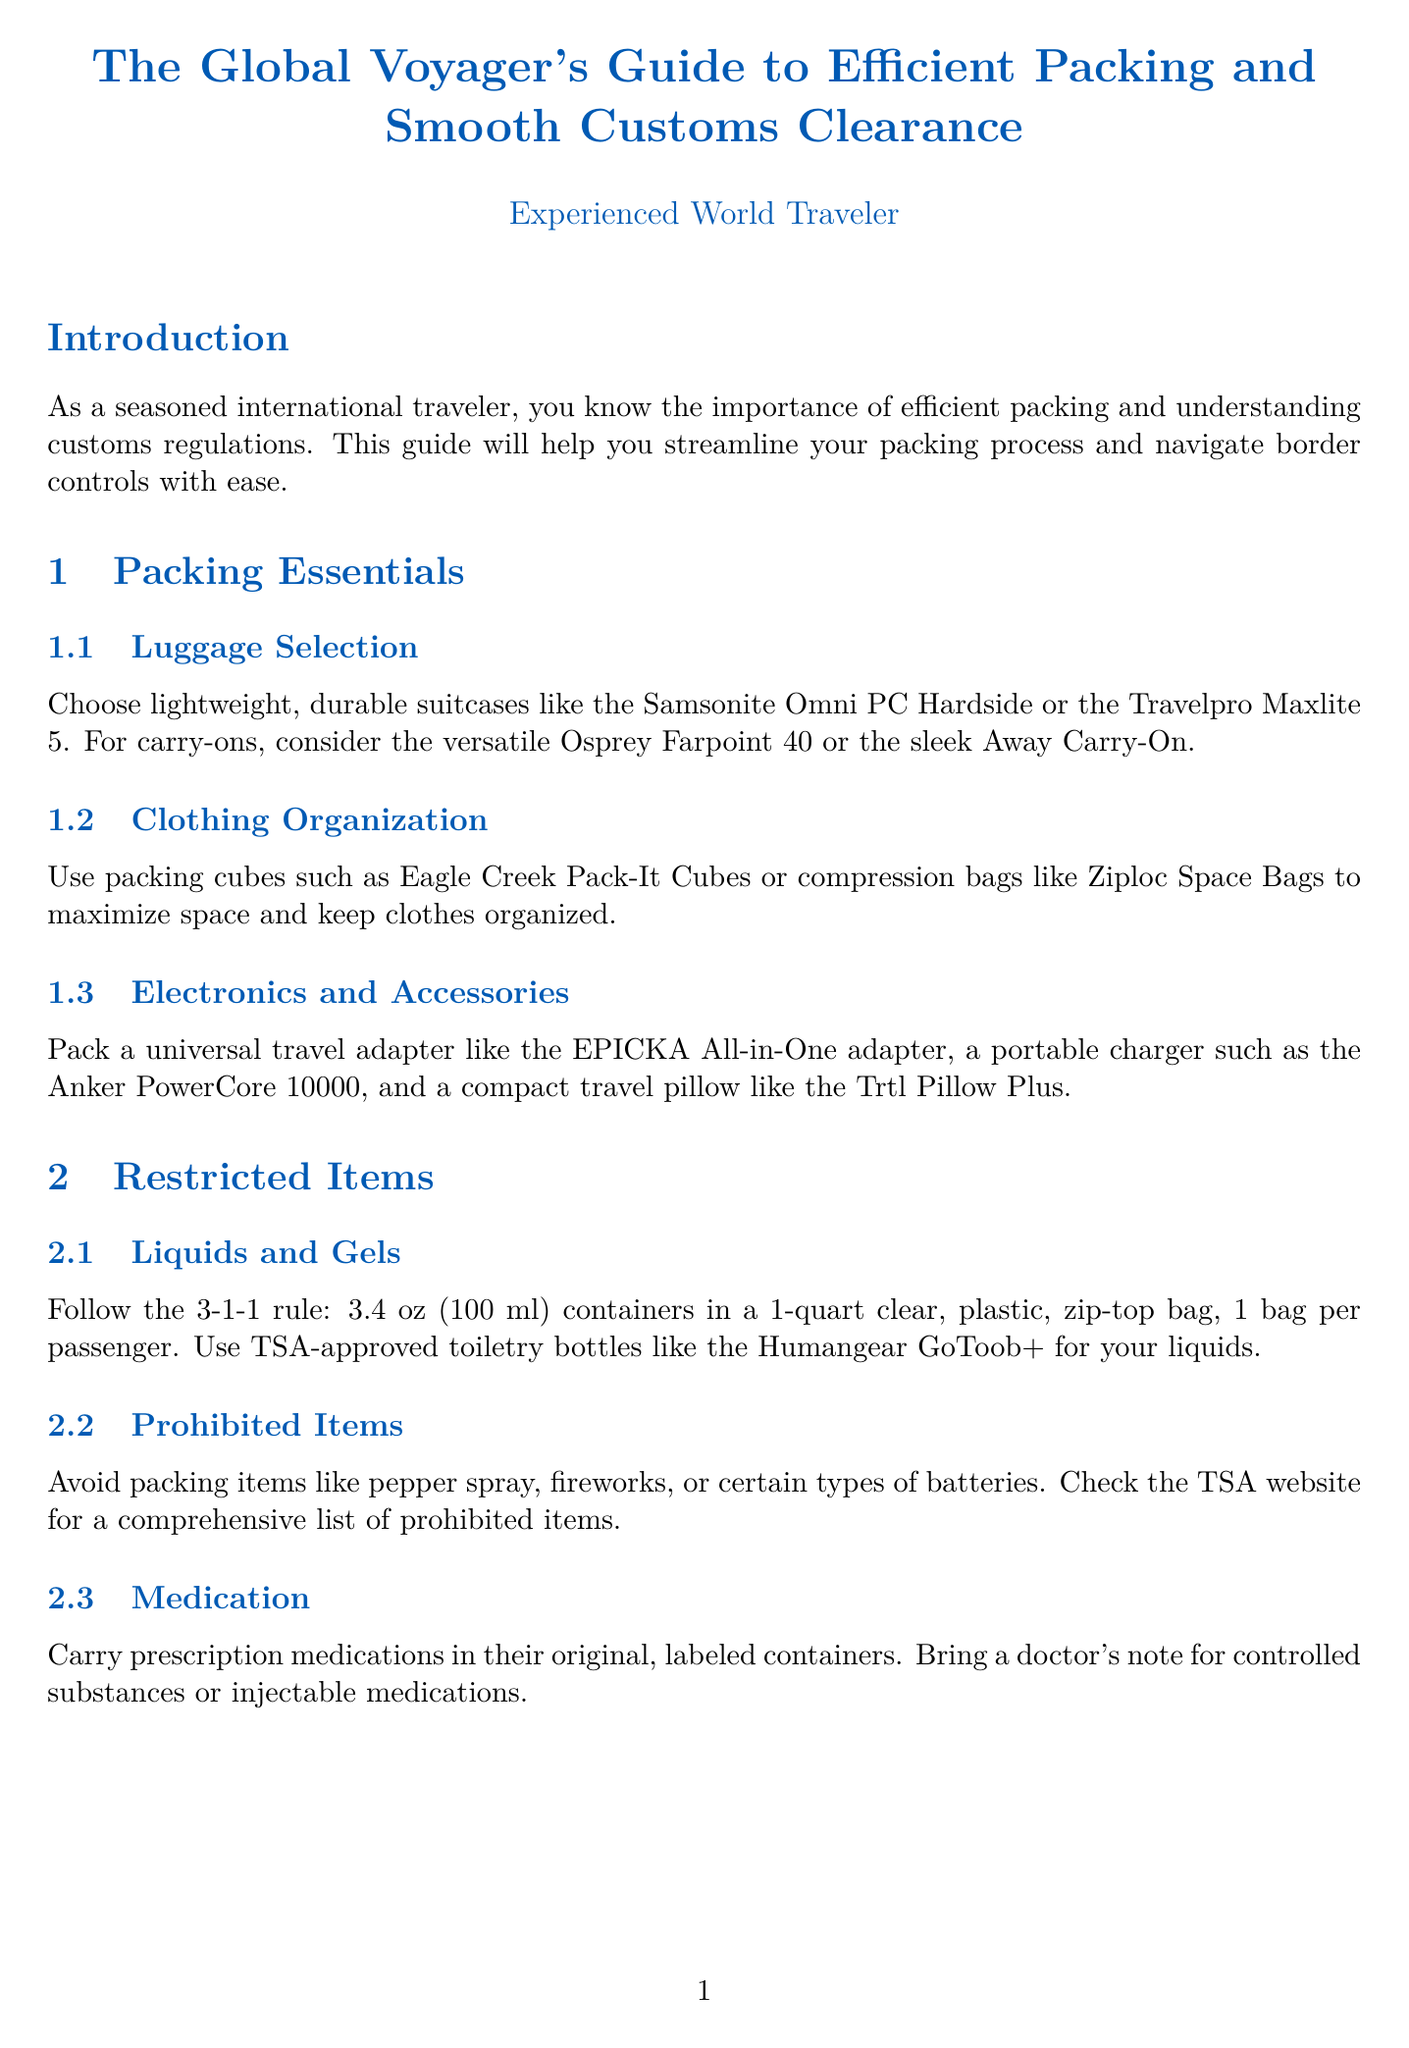what is the title of the document? The title of the document is provided in the title section, which is "The Global Voyager's Guide to Efficient Packing and Smooth Customs Clearance."
Answer: The Global Voyager's Guide to Efficient Packing and Smooth Customs Clearance what is the maximum size for liquid containers? The document specifies that the maximum size for liquid containers is 3.4 oz (100 ml).
Answer: 3.4 oz (100 ml) how many cigarettes can you bring duty-free into the US? The document mentions that for most travelers, the US allows 200 cigarettes duty-free.
Answer: 200 cigarettes what does the 3-1-1 rule refer to? The 3-1-1 rule refers to the quantity and packaging requirements for liquids in carry-on luggage.
Answer: liquids in carry-on luggage which travel adapter is recommended in the packing essentials? The recommended travel adapter mentioned in the packing essentials is the EPICKA All-in-One adapter.
Answer: EPICKA All-in-One adapter what should you do with prescription medications? The guide states to carry prescription medications in their original, labeled containers.
Answer: original, labeled containers what is a benefit of using Global Entry? The document states that applying for Global Entry expedites security and customs processes in the US and partner countries.
Answer: expedites security and customs processes what type of items must always be declared? The document specifies that items such as food, plants, or large sums of cash must always be declared.
Answer: food, plants, or large sums of cash what should you use for storing travel documents? The guide recommends using apps like TripIt or App in the Air for storing digital copies of travel documents.
Answer: TripIt or App in the Air 